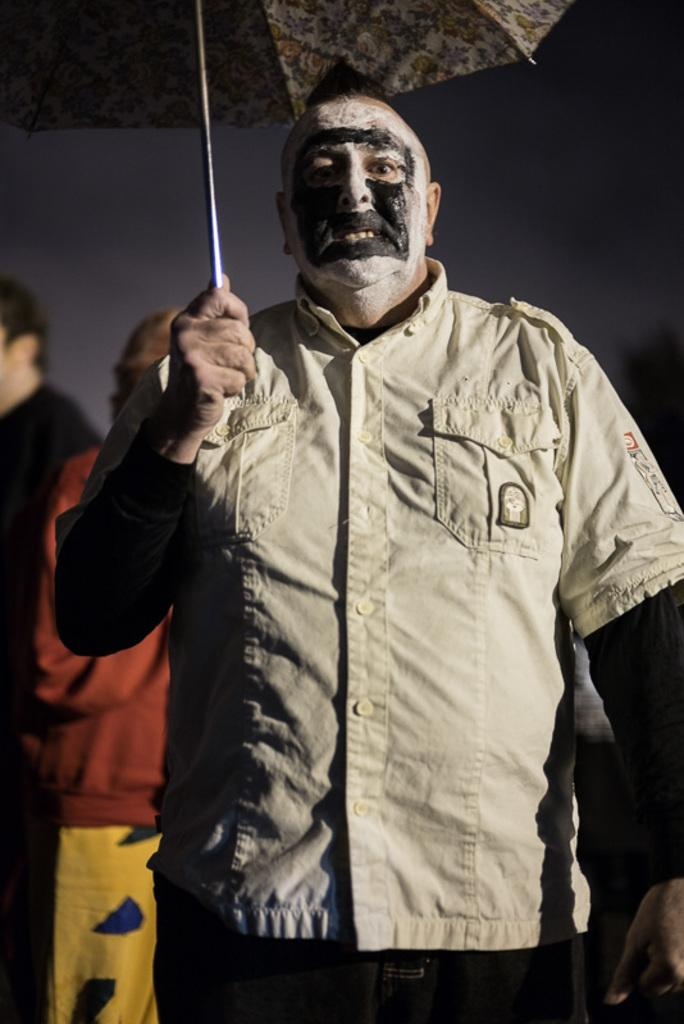How many persons are in the image? There are persons in the image. What are the persons wearing? The persons are wearing clothes. Can you describe the position of the person in the middle? The person in the middle is holding an umbrella with his hand. Is there a payment being made in the image? There is no mention of payment in the image, so it cannot be determined from the image. 